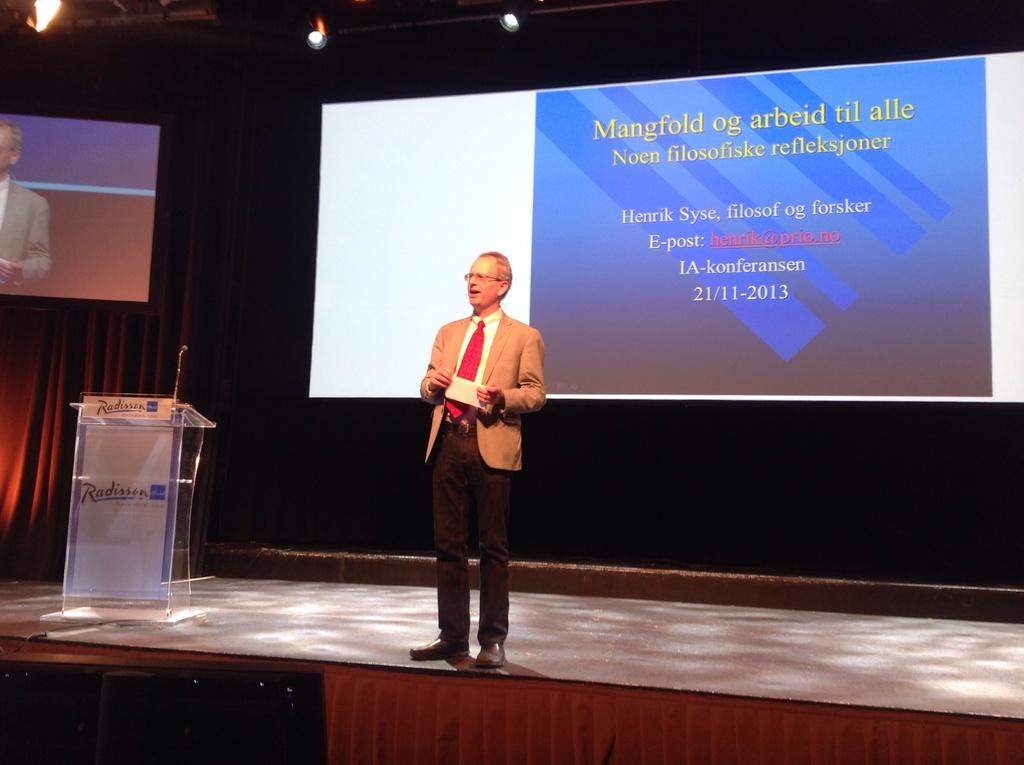<image>
Create a compact narrative representing the image presented. A man stands on stage at a Radisson hotel presenting with slides on a screen behind him. 